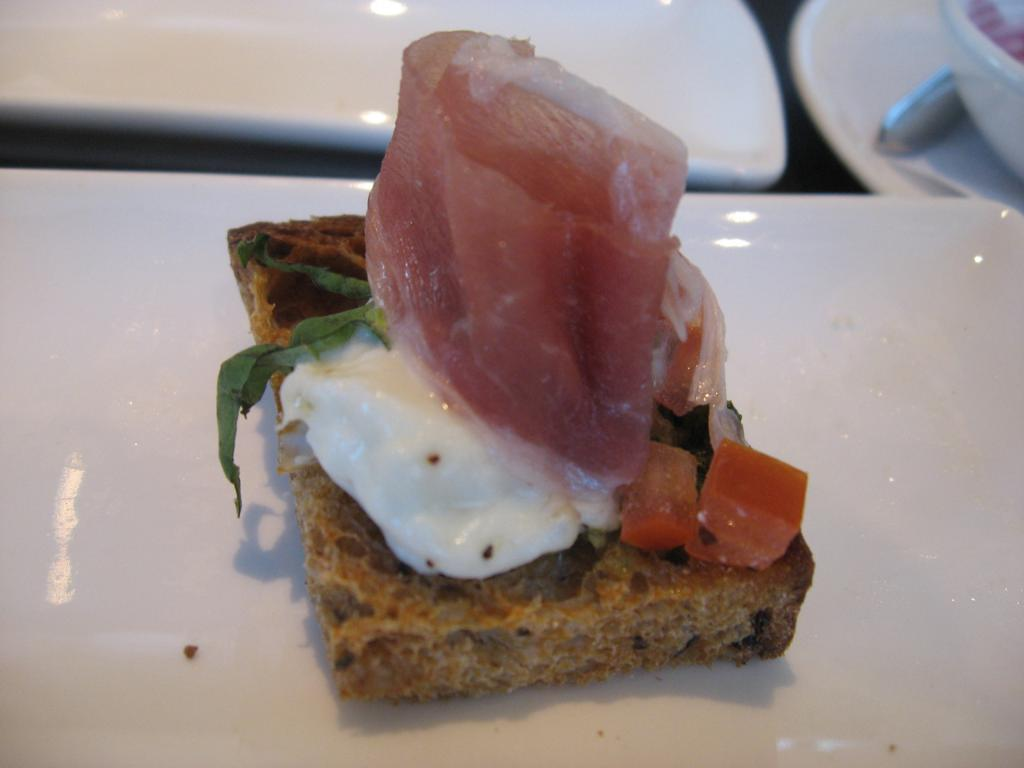What is placed on the white surface in the image? There is an eatable item placed on a white surface. Can you describe the surroundings of the eatable item? There are chairs visible in the image. What type of fowl can be seen flying in the image? There is no fowl visible in the image; it only features an eatable item on a white surface and chairs. 